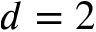<formula> <loc_0><loc_0><loc_500><loc_500>d = 2</formula> 